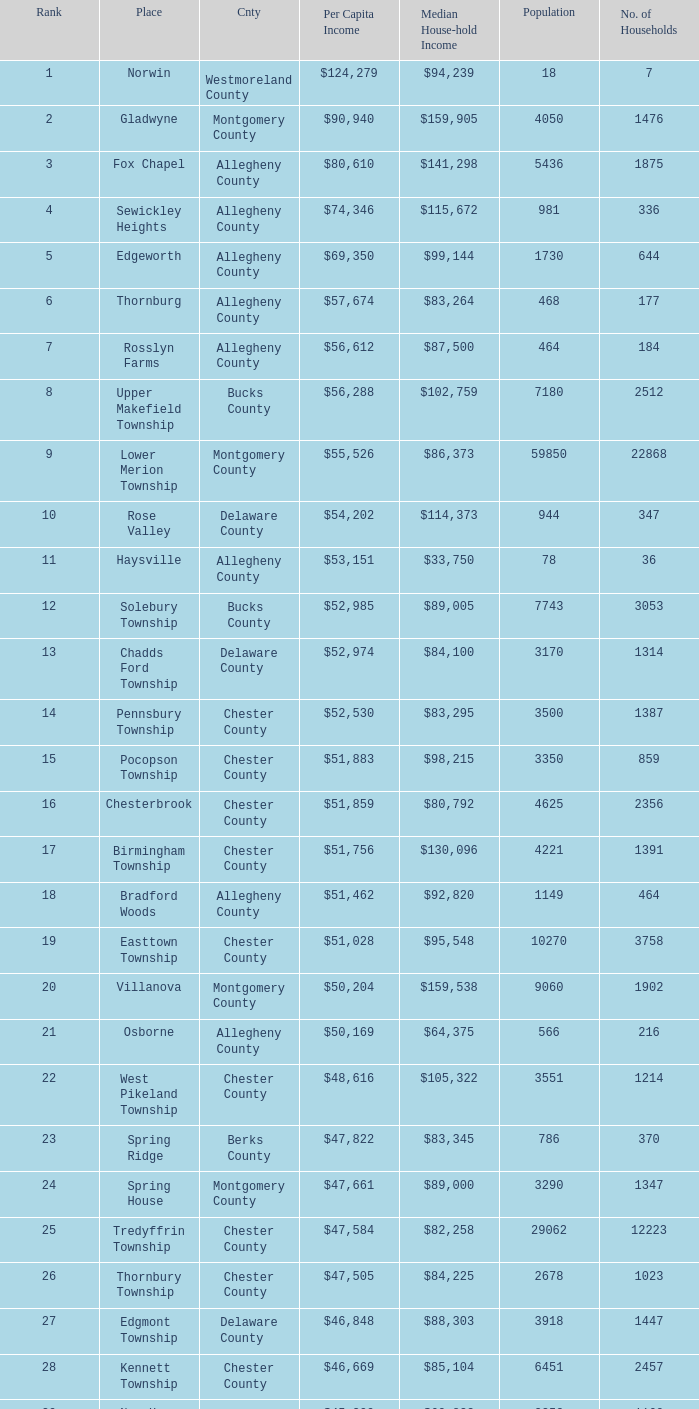What county has 2053 households?  Chester County. 